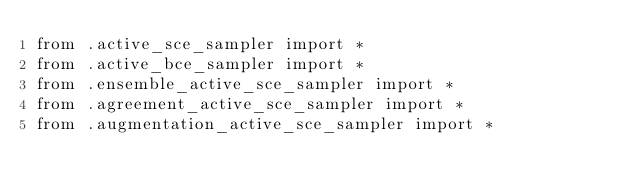<code> <loc_0><loc_0><loc_500><loc_500><_Python_>from .active_sce_sampler import *
from .active_bce_sampler import * 
from .ensemble_active_sce_sampler import * 
from .agreement_active_sce_sampler import * 
from .augmentation_active_sce_sampler import *
</code> 